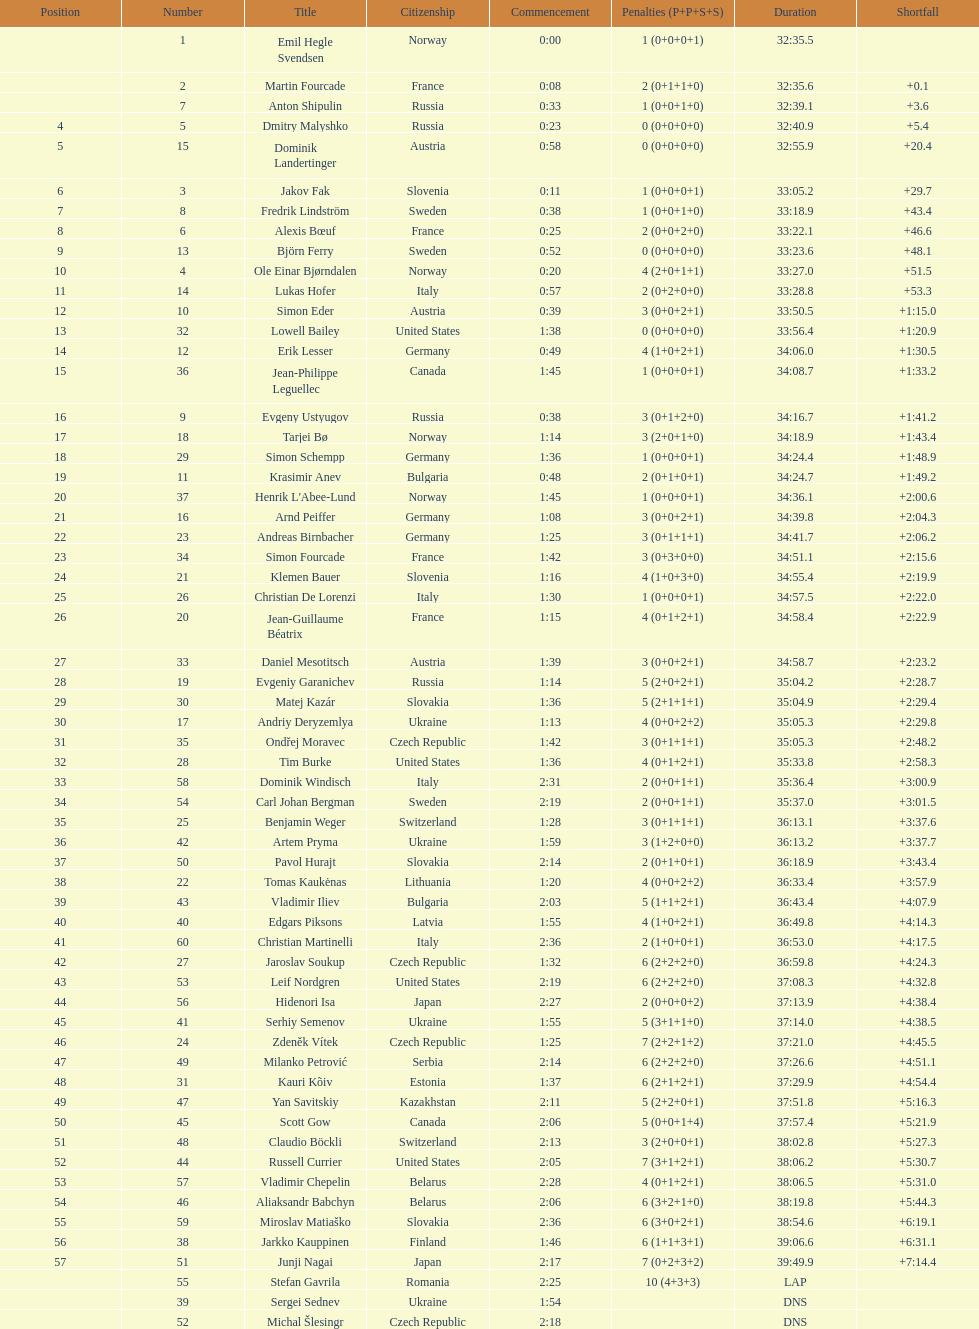How many finished in not less than 35:00? 30. 